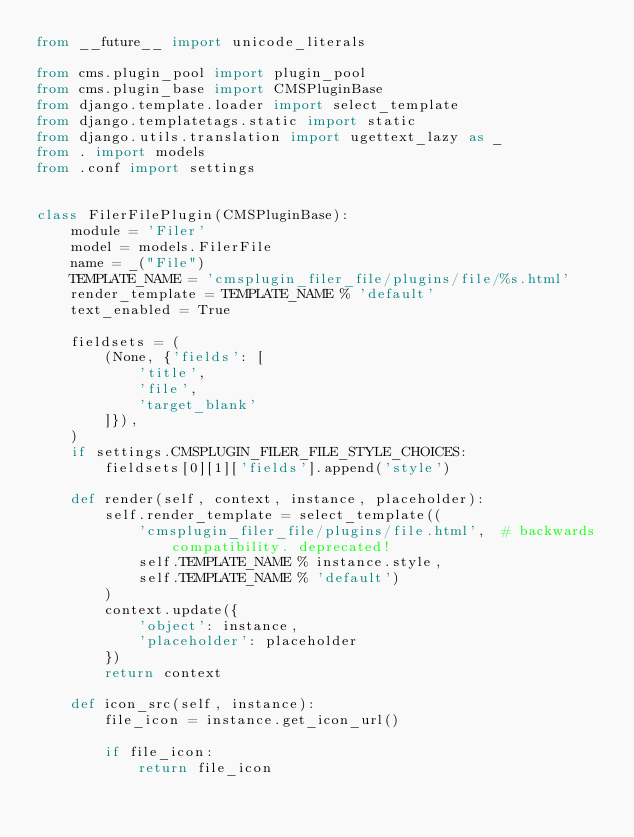Convert code to text. <code><loc_0><loc_0><loc_500><loc_500><_Python_>from __future__ import unicode_literals

from cms.plugin_pool import plugin_pool
from cms.plugin_base import CMSPluginBase
from django.template.loader import select_template
from django.templatetags.static import static
from django.utils.translation import ugettext_lazy as _
from . import models
from .conf import settings


class FilerFilePlugin(CMSPluginBase):
    module = 'Filer'
    model = models.FilerFile
    name = _("File")
    TEMPLATE_NAME = 'cmsplugin_filer_file/plugins/file/%s.html'
    render_template = TEMPLATE_NAME % 'default'
    text_enabled = True

    fieldsets = (
        (None, {'fields': [
            'title',
            'file',
            'target_blank'
        ]}),
    )
    if settings.CMSPLUGIN_FILER_FILE_STYLE_CHOICES:
        fieldsets[0][1]['fields'].append('style')

    def render(self, context, instance, placeholder):
        self.render_template = select_template((
            'cmsplugin_filer_file/plugins/file.html',  # backwards compatibility. deprecated!
            self.TEMPLATE_NAME % instance.style,
            self.TEMPLATE_NAME % 'default')
        )
        context.update({
            'object': instance,
            'placeholder': placeholder
        })
        return context

    def icon_src(self, instance):
        file_icon = instance.get_icon_url()

        if file_icon:
            return file_icon</code> 